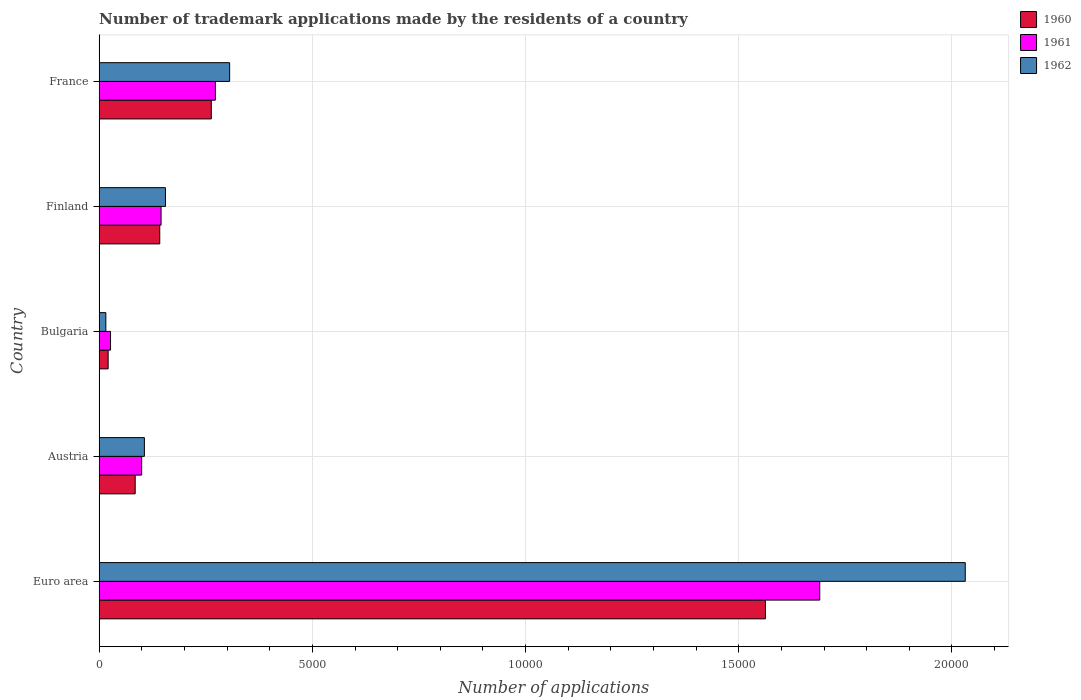How many different coloured bars are there?
Provide a short and direct response. 3. Are the number of bars per tick equal to the number of legend labels?
Ensure brevity in your answer.  Yes. Are the number of bars on each tick of the Y-axis equal?
Provide a succinct answer. Yes. How many bars are there on the 5th tick from the top?
Provide a short and direct response. 3. What is the label of the 4th group of bars from the top?
Ensure brevity in your answer.  Austria. What is the number of trademark applications made by the residents in 1962 in France?
Your answer should be very brief. 3060. Across all countries, what is the maximum number of trademark applications made by the residents in 1962?
Your response must be concise. 2.03e+04. Across all countries, what is the minimum number of trademark applications made by the residents in 1960?
Keep it short and to the point. 211. What is the total number of trademark applications made by the residents in 1962 in the graph?
Give a very brief answer. 2.61e+04. What is the difference between the number of trademark applications made by the residents in 1962 in Austria and that in France?
Your answer should be compact. -1999. What is the difference between the number of trademark applications made by the residents in 1961 in Finland and the number of trademark applications made by the residents in 1960 in France?
Ensure brevity in your answer.  -1178. What is the average number of trademark applications made by the residents in 1961 per country?
Offer a terse response. 4468.2. What is the difference between the number of trademark applications made by the residents in 1962 and number of trademark applications made by the residents in 1961 in Austria?
Ensure brevity in your answer.  64. What is the ratio of the number of trademark applications made by the residents in 1961 in Austria to that in Bulgaria?
Offer a terse response. 3.73. Is the difference between the number of trademark applications made by the residents in 1962 in Bulgaria and Euro area greater than the difference between the number of trademark applications made by the residents in 1961 in Bulgaria and Euro area?
Make the answer very short. No. What is the difference between the highest and the second highest number of trademark applications made by the residents in 1961?
Keep it short and to the point. 1.42e+04. What is the difference between the highest and the lowest number of trademark applications made by the residents in 1960?
Your answer should be compact. 1.54e+04. In how many countries, is the number of trademark applications made by the residents in 1961 greater than the average number of trademark applications made by the residents in 1961 taken over all countries?
Your answer should be very brief. 1. Is the sum of the number of trademark applications made by the residents in 1960 in Austria and Finland greater than the maximum number of trademark applications made by the residents in 1962 across all countries?
Your answer should be very brief. No. What does the 1st bar from the bottom in Bulgaria represents?
Offer a very short reply. 1960. Is it the case that in every country, the sum of the number of trademark applications made by the residents in 1962 and number of trademark applications made by the residents in 1960 is greater than the number of trademark applications made by the residents in 1961?
Provide a short and direct response. Yes. How many bars are there?
Keep it short and to the point. 15. Are all the bars in the graph horizontal?
Give a very brief answer. Yes. How many countries are there in the graph?
Provide a short and direct response. 5. Does the graph contain any zero values?
Your response must be concise. No. How are the legend labels stacked?
Your answer should be compact. Vertical. What is the title of the graph?
Provide a succinct answer. Number of trademark applications made by the residents of a country. What is the label or title of the X-axis?
Provide a succinct answer. Number of applications. What is the label or title of the Y-axis?
Provide a succinct answer. Country. What is the Number of applications in 1960 in Euro area?
Your answer should be very brief. 1.56e+04. What is the Number of applications of 1961 in Euro area?
Keep it short and to the point. 1.69e+04. What is the Number of applications in 1962 in Euro area?
Give a very brief answer. 2.03e+04. What is the Number of applications of 1960 in Austria?
Provide a succinct answer. 845. What is the Number of applications of 1961 in Austria?
Ensure brevity in your answer.  997. What is the Number of applications in 1962 in Austria?
Give a very brief answer. 1061. What is the Number of applications of 1960 in Bulgaria?
Your answer should be compact. 211. What is the Number of applications of 1961 in Bulgaria?
Offer a terse response. 267. What is the Number of applications of 1962 in Bulgaria?
Give a very brief answer. 157. What is the Number of applications in 1960 in Finland?
Make the answer very short. 1421. What is the Number of applications of 1961 in Finland?
Your response must be concise. 1452. What is the Number of applications in 1962 in Finland?
Offer a very short reply. 1555. What is the Number of applications in 1960 in France?
Offer a terse response. 2630. What is the Number of applications of 1961 in France?
Provide a short and direct response. 2726. What is the Number of applications of 1962 in France?
Give a very brief answer. 3060. Across all countries, what is the maximum Number of applications in 1960?
Offer a terse response. 1.56e+04. Across all countries, what is the maximum Number of applications of 1961?
Ensure brevity in your answer.  1.69e+04. Across all countries, what is the maximum Number of applications of 1962?
Provide a short and direct response. 2.03e+04. Across all countries, what is the minimum Number of applications in 1960?
Keep it short and to the point. 211. Across all countries, what is the minimum Number of applications in 1961?
Give a very brief answer. 267. Across all countries, what is the minimum Number of applications in 1962?
Your answer should be very brief. 157. What is the total Number of applications of 1960 in the graph?
Your answer should be very brief. 2.07e+04. What is the total Number of applications of 1961 in the graph?
Your response must be concise. 2.23e+04. What is the total Number of applications of 1962 in the graph?
Your answer should be compact. 2.61e+04. What is the difference between the Number of applications of 1960 in Euro area and that in Austria?
Your answer should be very brief. 1.48e+04. What is the difference between the Number of applications in 1961 in Euro area and that in Austria?
Keep it short and to the point. 1.59e+04. What is the difference between the Number of applications of 1962 in Euro area and that in Austria?
Your response must be concise. 1.92e+04. What is the difference between the Number of applications of 1960 in Euro area and that in Bulgaria?
Provide a succinct answer. 1.54e+04. What is the difference between the Number of applications in 1961 in Euro area and that in Bulgaria?
Offer a very short reply. 1.66e+04. What is the difference between the Number of applications in 1962 in Euro area and that in Bulgaria?
Your answer should be compact. 2.02e+04. What is the difference between the Number of applications of 1960 in Euro area and that in Finland?
Your response must be concise. 1.42e+04. What is the difference between the Number of applications of 1961 in Euro area and that in Finland?
Offer a very short reply. 1.54e+04. What is the difference between the Number of applications of 1962 in Euro area and that in Finland?
Provide a succinct answer. 1.88e+04. What is the difference between the Number of applications of 1960 in Euro area and that in France?
Offer a terse response. 1.30e+04. What is the difference between the Number of applications of 1961 in Euro area and that in France?
Your answer should be very brief. 1.42e+04. What is the difference between the Number of applications of 1962 in Euro area and that in France?
Offer a very short reply. 1.73e+04. What is the difference between the Number of applications of 1960 in Austria and that in Bulgaria?
Your answer should be compact. 634. What is the difference between the Number of applications in 1961 in Austria and that in Bulgaria?
Offer a very short reply. 730. What is the difference between the Number of applications of 1962 in Austria and that in Bulgaria?
Your answer should be compact. 904. What is the difference between the Number of applications in 1960 in Austria and that in Finland?
Give a very brief answer. -576. What is the difference between the Number of applications of 1961 in Austria and that in Finland?
Your answer should be compact. -455. What is the difference between the Number of applications of 1962 in Austria and that in Finland?
Make the answer very short. -494. What is the difference between the Number of applications of 1960 in Austria and that in France?
Your answer should be very brief. -1785. What is the difference between the Number of applications in 1961 in Austria and that in France?
Your answer should be very brief. -1729. What is the difference between the Number of applications of 1962 in Austria and that in France?
Ensure brevity in your answer.  -1999. What is the difference between the Number of applications of 1960 in Bulgaria and that in Finland?
Keep it short and to the point. -1210. What is the difference between the Number of applications of 1961 in Bulgaria and that in Finland?
Give a very brief answer. -1185. What is the difference between the Number of applications in 1962 in Bulgaria and that in Finland?
Ensure brevity in your answer.  -1398. What is the difference between the Number of applications in 1960 in Bulgaria and that in France?
Your response must be concise. -2419. What is the difference between the Number of applications in 1961 in Bulgaria and that in France?
Your answer should be compact. -2459. What is the difference between the Number of applications of 1962 in Bulgaria and that in France?
Ensure brevity in your answer.  -2903. What is the difference between the Number of applications of 1960 in Finland and that in France?
Make the answer very short. -1209. What is the difference between the Number of applications in 1961 in Finland and that in France?
Make the answer very short. -1274. What is the difference between the Number of applications of 1962 in Finland and that in France?
Provide a succinct answer. -1505. What is the difference between the Number of applications in 1960 in Euro area and the Number of applications in 1961 in Austria?
Provide a short and direct response. 1.46e+04. What is the difference between the Number of applications of 1960 in Euro area and the Number of applications of 1962 in Austria?
Offer a terse response. 1.46e+04. What is the difference between the Number of applications of 1961 in Euro area and the Number of applications of 1962 in Austria?
Make the answer very short. 1.58e+04. What is the difference between the Number of applications in 1960 in Euro area and the Number of applications in 1961 in Bulgaria?
Offer a terse response. 1.54e+04. What is the difference between the Number of applications of 1960 in Euro area and the Number of applications of 1962 in Bulgaria?
Keep it short and to the point. 1.55e+04. What is the difference between the Number of applications in 1961 in Euro area and the Number of applications in 1962 in Bulgaria?
Your answer should be compact. 1.67e+04. What is the difference between the Number of applications of 1960 in Euro area and the Number of applications of 1961 in Finland?
Your response must be concise. 1.42e+04. What is the difference between the Number of applications in 1960 in Euro area and the Number of applications in 1962 in Finland?
Keep it short and to the point. 1.41e+04. What is the difference between the Number of applications in 1961 in Euro area and the Number of applications in 1962 in Finland?
Keep it short and to the point. 1.53e+04. What is the difference between the Number of applications of 1960 in Euro area and the Number of applications of 1961 in France?
Your response must be concise. 1.29e+04. What is the difference between the Number of applications in 1960 in Euro area and the Number of applications in 1962 in France?
Keep it short and to the point. 1.26e+04. What is the difference between the Number of applications in 1961 in Euro area and the Number of applications in 1962 in France?
Keep it short and to the point. 1.38e+04. What is the difference between the Number of applications in 1960 in Austria and the Number of applications in 1961 in Bulgaria?
Provide a succinct answer. 578. What is the difference between the Number of applications in 1960 in Austria and the Number of applications in 1962 in Bulgaria?
Give a very brief answer. 688. What is the difference between the Number of applications of 1961 in Austria and the Number of applications of 1962 in Bulgaria?
Your answer should be very brief. 840. What is the difference between the Number of applications in 1960 in Austria and the Number of applications in 1961 in Finland?
Offer a very short reply. -607. What is the difference between the Number of applications in 1960 in Austria and the Number of applications in 1962 in Finland?
Provide a short and direct response. -710. What is the difference between the Number of applications of 1961 in Austria and the Number of applications of 1962 in Finland?
Keep it short and to the point. -558. What is the difference between the Number of applications of 1960 in Austria and the Number of applications of 1961 in France?
Your answer should be very brief. -1881. What is the difference between the Number of applications in 1960 in Austria and the Number of applications in 1962 in France?
Keep it short and to the point. -2215. What is the difference between the Number of applications of 1961 in Austria and the Number of applications of 1962 in France?
Your answer should be compact. -2063. What is the difference between the Number of applications in 1960 in Bulgaria and the Number of applications in 1961 in Finland?
Make the answer very short. -1241. What is the difference between the Number of applications of 1960 in Bulgaria and the Number of applications of 1962 in Finland?
Your response must be concise. -1344. What is the difference between the Number of applications in 1961 in Bulgaria and the Number of applications in 1962 in Finland?
Your answer should be very brief. -1288. What is the difference between the Number of applications in 1960 in Bulgaria and the Number of applications in 1961 in France?
Make the answer very short. -2515. What is the difference between the Number of applications of 1960 in Bulgaria and the Number of applications of 1962 in France?
Provide a succinct answer. -2849. What is the difference between the Number of applications in 1961 in Bulgaria and the Number of applications in 1962 in France?
Make the answer very short. -2793. What is the difference between the Number of applications in 1960 in Finland and the Number of applications in 1961 in France?
Your answer should be very brief. -1305. What is the difference between the Number of applications of 1960 in Finland and the Number of applications of 1962 in France?
Your answer should be very brief. -1639. What is the difference between the Number of applications in 1961 in Finland and the Number of applications in 1962 in France?
Offer a very short reply. -1608. What is the average Number of applications in 1960 per country?
Keep it short and to the point. 4146.4. What is the average Number of applications in 1961 per country?
Make the answer very short. 4468.2. What is the average Number of applications of 1962 per country?
Keep it short and to the point. 5228.8. What is the difference between the Number of applications in 1960 and Number of applications in 1961 in Euro area?
Your answer should be compact. -1274. What is the difference between the Number of applications of 1960 and Number of applications of 1962 in Euro area?
Provide a succinct answer. -4686. What is the difference between the Number of applications in 1961 and Number of applications in 1962 in Euro area?
Provide a short and direct response. -3412. What is the difference between the Number of applications of 1960 and Number of applications of 1961 in Austria?
Your response must be concise. -152. What is the difference between the Number of applications of 1960 and Number of applications of 1962 in Austria?
Your answer should be compact. -216. What is the difference between the Number of applications in 1961 and Number of applications in 1962 in Austria?
Give a very brief answer. -64. What is the difference between the Number of applications of 1960 and Number of applications of 1961 in Bulgaria?
Your answer should be compact. -56. What is the difference between the Number of applications of 1961 and Number of applications of 1962 in Bulgaria?
Offer a very short reply. 110. What is the difference between the Number of applications in 1960 and Number of applications in 1961 in Finland?
Your answer should be compact. -31. What is the difference between the Number of applications in 1960 and Number of applications in 1962 in Finland?
Your answer should be very brief. -134. What is the difference between the Number of applications in 1961 and Number of applications in 1962 in Finland?
Keep it short and to the point. -103. What is the difference between the Number of applications of 1960 and Number of applications of 1961 in France?
Ensure brevity in your answer.  -96. What is the difference between the Number of applications in 1960 and Number of applications in 1962 in France?
Your answer should be very brief. -430. What is the difference between the Number of applications of 1961 and Number of applications of 1962 in France?
Provide a succinct answer. -334. What is the ratio of the Number of applications of 1960 in Euro area to that in Austria?
Keep it short and to the point. 18.49. What is the ratio of the Number of applications of 1961 in Euro area to that in Austria?
Give a very brief answer. 16.95. What is the ratio of the Number of applications of 1962 in Euro area to that in Austria?
Provide a short and direct response. 19.14. What is the ratio of the Number of applications of 1960 in Euro area to that in Bulgaria?
Your answer should be compact. 74.05. What is the ratio of the Number of applications in 1961 in Euro area to that in Bulgaria?
Offer a very short reply. 63.29. What is the ratio of the Number of applications of 1962 in Euro area to that in Bulgaria?
Offer a very short reply. 129.37. What is the ratio of the Number of applications of 1960 in Euro area to that in Finland?
Offer a very short reply. 11. What is the ratio of the Number of applications of 1961 in Euro area to that in Finland?
Offer a terse response. 11.64. What is the ratio of the Number of applications in 1962 in Euro area to that in Finland?
Give a very brief answer. 13.06. What is the ratio of the Number of applications of 1960 in Euro area to that in France?
Offer a very short reply. 5.94. What is the ratio of the Number of applications in 1961 in Euro area to that in France?
Ensure brevity in your answer.  6.2. What is the ratio of the Number of applications of 1962 in Euro area to that in France?
Offer a very short reply. 6.64. What is the ratio of the Number of applications of 1960 in Austria to that in Bulgaria?
Ensure brevity in your answer.  4. What is the ratio of the Number of applications in 1961 in Austria to that in Bulgaria?
Your response must be concise. 3.73. What is the ratio of the Number of applications in 1962 in Austria to that in Bulgaria?
Give a very brief answer. 6.76. What is the ratio of the Number of applications in 1960 in Austria to that in Finland?
Your answer should be compact. 0.59. What is the ratio of the Number of applications of 1961 in Austria to that in Finland?
Ensure brevity in your answer.  0.69. What is the ratio of the Number of applications in 1962 in Austria to that in Finland?
Offer a very short reply. 0.68. What is the ratio of the Number of applications of 1960 in Austria to that in France?
Ensure brevity in your answer.  0.32. What is the ratio of the Number of applications of 1961 in Austria to that in France?
Offer a terse response. 0.37. What is the ratio of the Number of applications in 1962 in Austria to that in France?
Provide a succinct answer. 0.35. What is the ratio of the Number of applications in 1960 in Bulgaria to that in Finland?
Provide a succinct answer. 0.15. What is the ratio of the Number of applications of 1961 in Bulgaria to that in Finland?
Provide a succinct answer. 0.18. What is the ratio of the Number of applications of 1962 in Bulgaria to that in Finland?
Provide a short and direct response. 0.1. What is the ratio of the Number of applications of 1960 in Bulgaria to that in France?
Make the answer very short. 0.08. What is the ratio of the Number of applications of 1961 in Bulgaria to that in France?
Make the answer very short. 0.1. What is the ratio of the Number of applications of 1962 in Bulgaria to that in France?
Make the answer very short. 0.05. What is the ratio of the Number of applications in 1960 in Finland to that in France?
Provide a succinct answer. 0.54. What is the ratio of the Number of applications of 1961 in Finland to that in France?
Offer a very short reply. 0.53. What is the ratio of the Number of applications in 1962 in Finland to that in France?
Your response must be concise. 0.51. What is the difference between the highest and the second highest Number of applications in 1960?
Offer a terse response. 1.30e+04. What is the difference between the highest and the second highest Number of applications of 1961?
Keep it short and to the point. 1.42e+04. What is the difference between the highest and the second highest Number of applications of 1962?
Make the answer very short. 1.73e+04. What is the difference between the highest and the lowest Number of applications in 1960?
Offer a very short reply. 1.54e+04. What is the difference between the highest and the lowest Number of applications in 1961?
Your response must be concise. 1.66e+04. What is the difference between the highest and the lowest Number of applications of 1962?
Offer a terse response. 2.02e+04. 